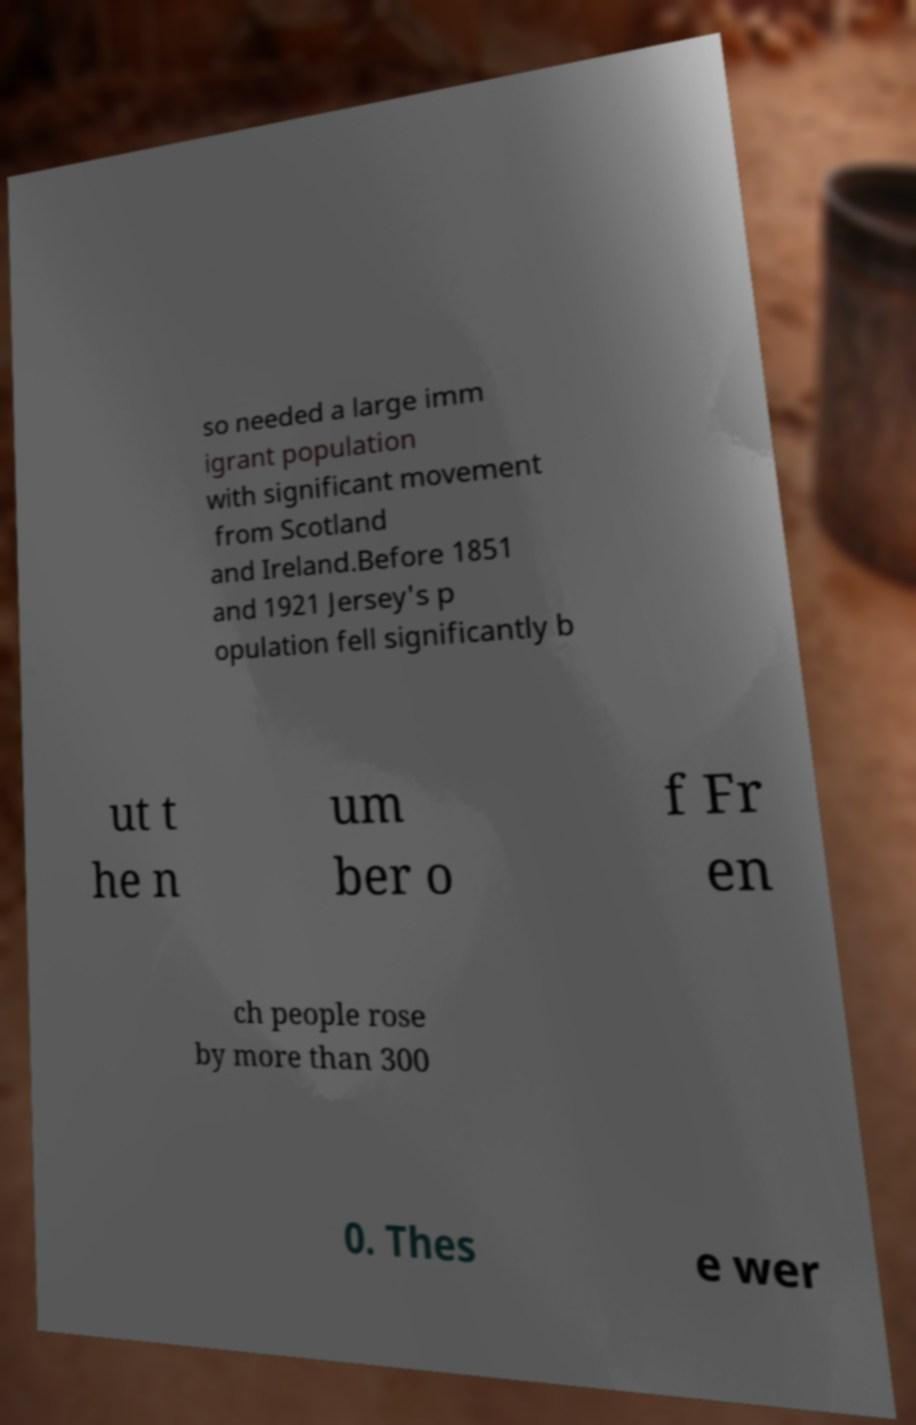For documentation purposes, I need the text within this image transcribed. Could you provide that? so needed a large imm igrant population with significant movement from Scotland and Ireland.Before 1851 and 1921 Jersey's p opulation fell significantly b ut t he n um ber o f Fr en ch people rose by more than 300 0. Thes e wer 